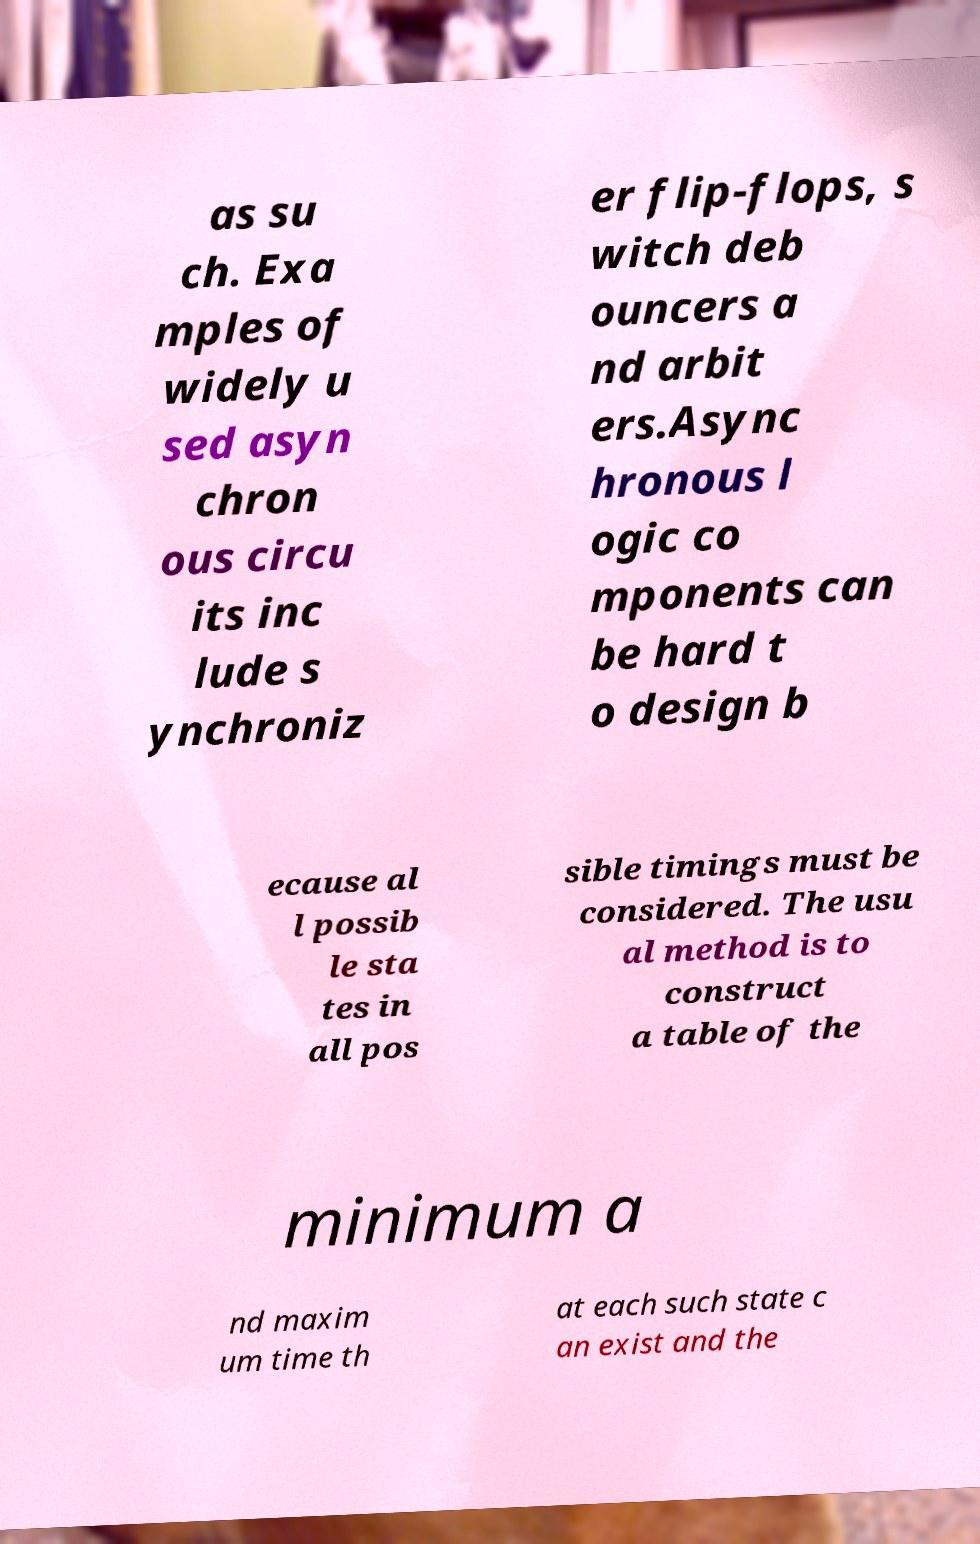Please identify and transcribe the text found in this image. as su ch. Exa mples of widely u sed asyn chron ous circu its inc lude s ynchroniz er flip-flops, s witch deb ouncers a nd arbit ers.Async hronous l ogic co mponents can be hard t o design b ecause al l possib le sta tes in all pos sible timings must be considered. The usu al method is to construct a table of the minimum a nd maxim um time th at each such state c an exist and the 